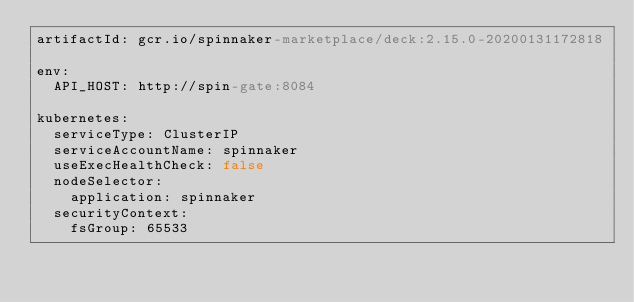<code> <loc_0><loc_0><loc_500><loc_500><_YAML_>artifactId: gcr.io/spinnaker-marketplace/deck:2.15.0-20200131172818

env:
  API_HOST: http://spin-gate:8084
  
kubernetes:
  serviceType: ClusterIP
  serviceAccountName: spinnaker
  useExecHealthCheck: false
  nodeSelector:
    application: spinnaker
  securityContext:
    fsGroup: 65533
</code> 